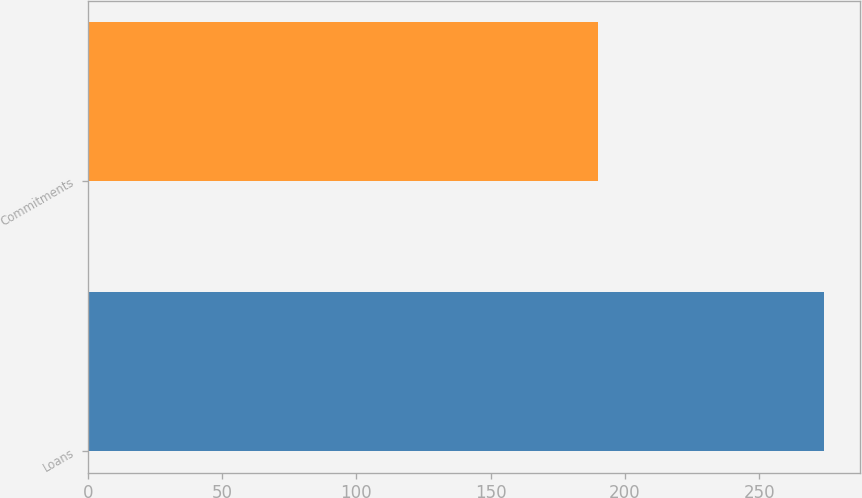Convert chart. <chart><loc_0><loc_0><loc_500><loc_500><bar_chart><fcel>Loans<fcel>Commitments<nl><fcel>274<fcel>190<nl></chart> 